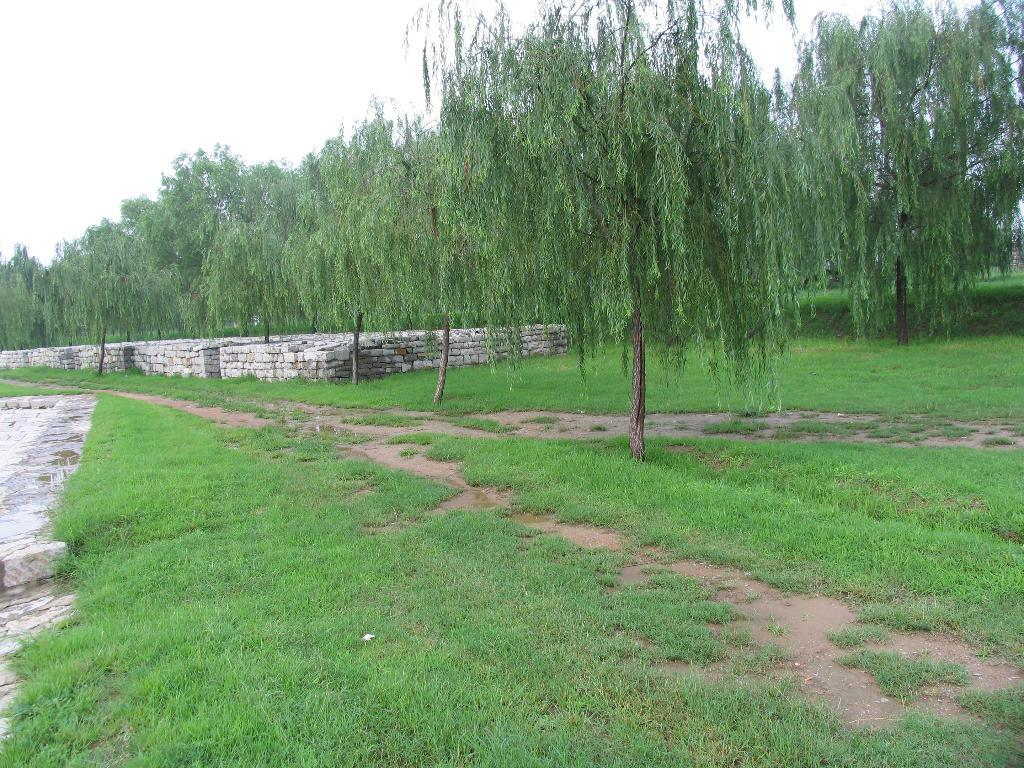What type of surface is visible in the image? There is ground in the image. What covers the ground in the image? The ground is covered with grass. What other natural elements can be seen in the image? There are trees visible in the image. How many balls are visible in the image? There are no balls present in the image. Is there any coal visible in the image? There is no coal present in the image. 